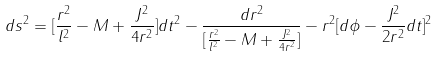<formula> <loc_0><loc_0><loc_500><loc_500>d s ^ { 2 } = [ \frac { r ^ { 2 } } { l ^ { 2 } } - M + \frac { J ^ { 2 } } { 4 r ^ { 2 } } ] d t ^ { 2 } - \frac { d r ^ { 2 } } { [ \frac { r ^ { 2 } } { l ^ { 2 } } - M + \frac { J ^ { 2 } } { 4 r ^ { 2 } } ] } - r ^ { 2 } [ d \phi - \frac { J ^ { 2 } } { 2 r ^ { 2 } } d t ] ^ { 2 }</formula> 